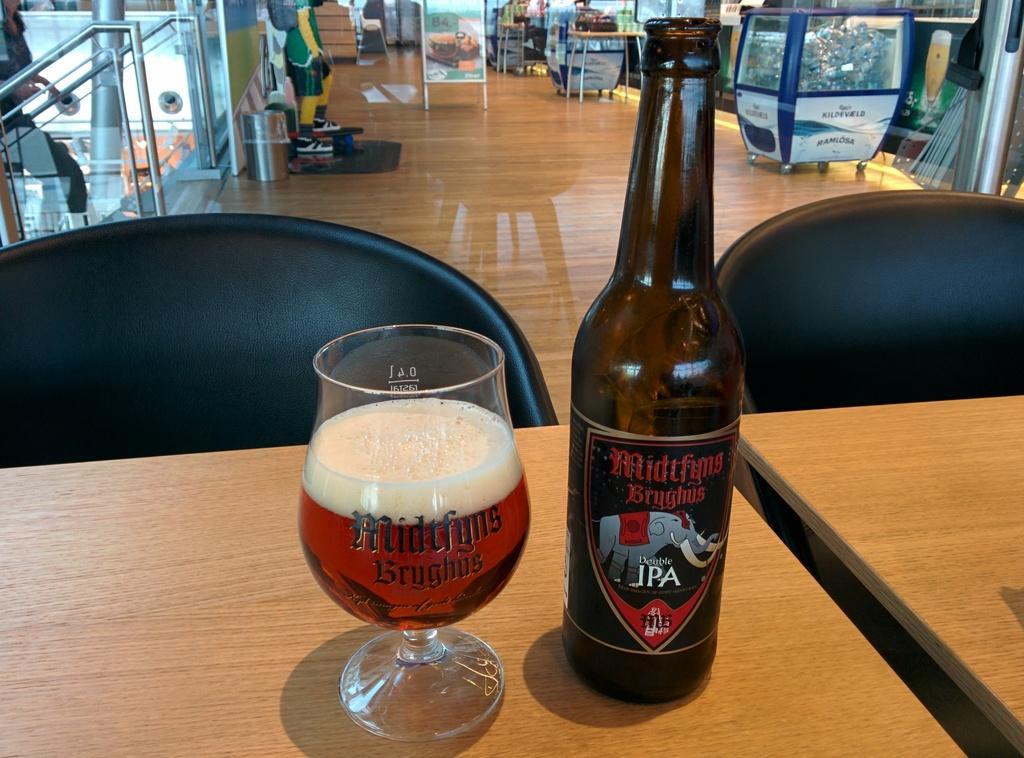<image>
Write a terse but informative summary of the picture. Bottle of Midtfyns Bryghus" next to a cup of beer. 